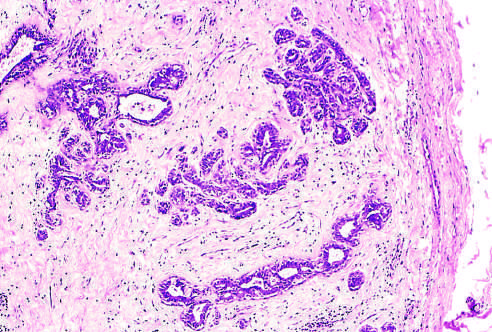does the surrounding lung delimit the tumor from the surrounding tissue?
Answer the question using a single word or phrase. No 